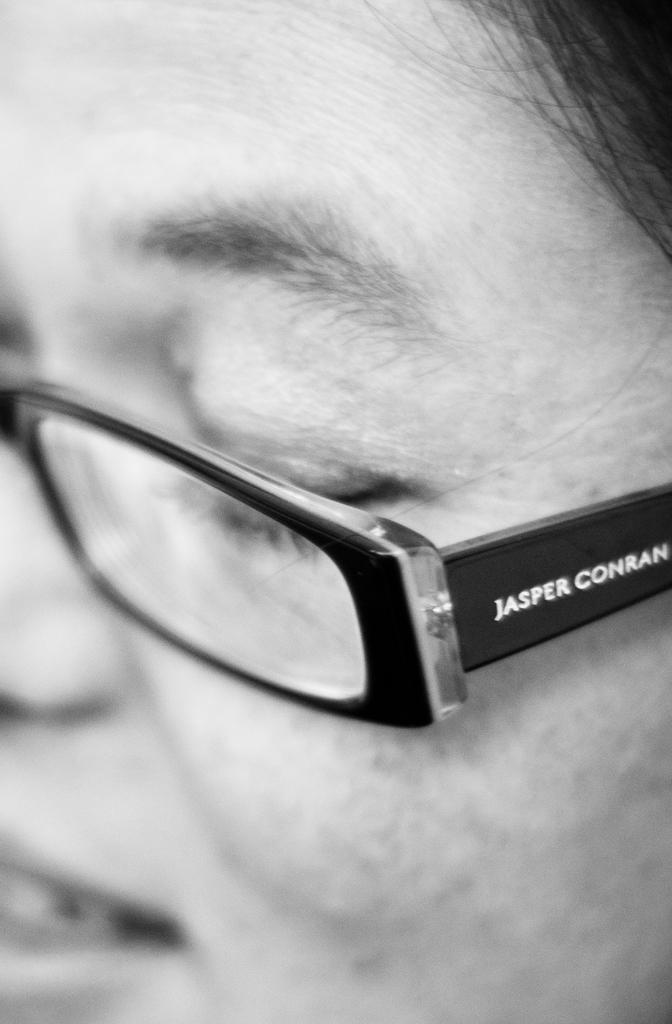What is the color scheme of the image? The image is black and white. Can you describe the person in the image? There is a person in the image, and they are wearing spectacles. Is there any text present in the image? Yes, there is text written on the image. Can you tell me how fast the person is running in the image? There is no indication of the person running in the image, as it is a still photograph. What time of day is depicted in the image? The image is black and white, so it is not possible to determine the time of day from the image alone. 